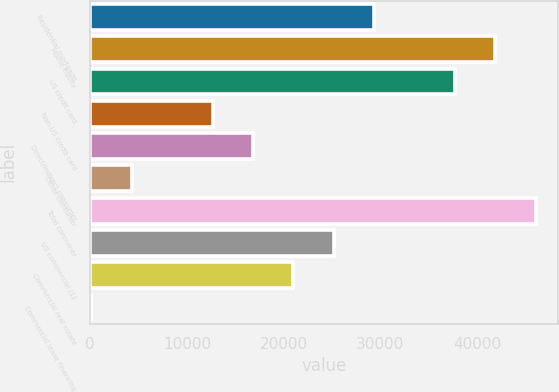Convert chart to OTSL. <chart><loc_0><loc_0><loc_500><loc_500><bar_chart><fcel>Residential mortgage<fcel>Home equity<fcel>US credit card<fcel>Non-US credit card<fcel>Direct/Indirect consumer<fcel>Other consumer<fcel>Total consumer<fcel>US commercial (1)<fcel>Commercial real estate<fcel>Commercial lease financing<nl><fcel>29357.3<fcel>41885<fcel>37709.1<fcel>12653.7<fcel>16829.6<fcel>4301.9<fcel>46060.9<fcel>25181.4<fcel>21005.5<fcel>126<nl></chart> 